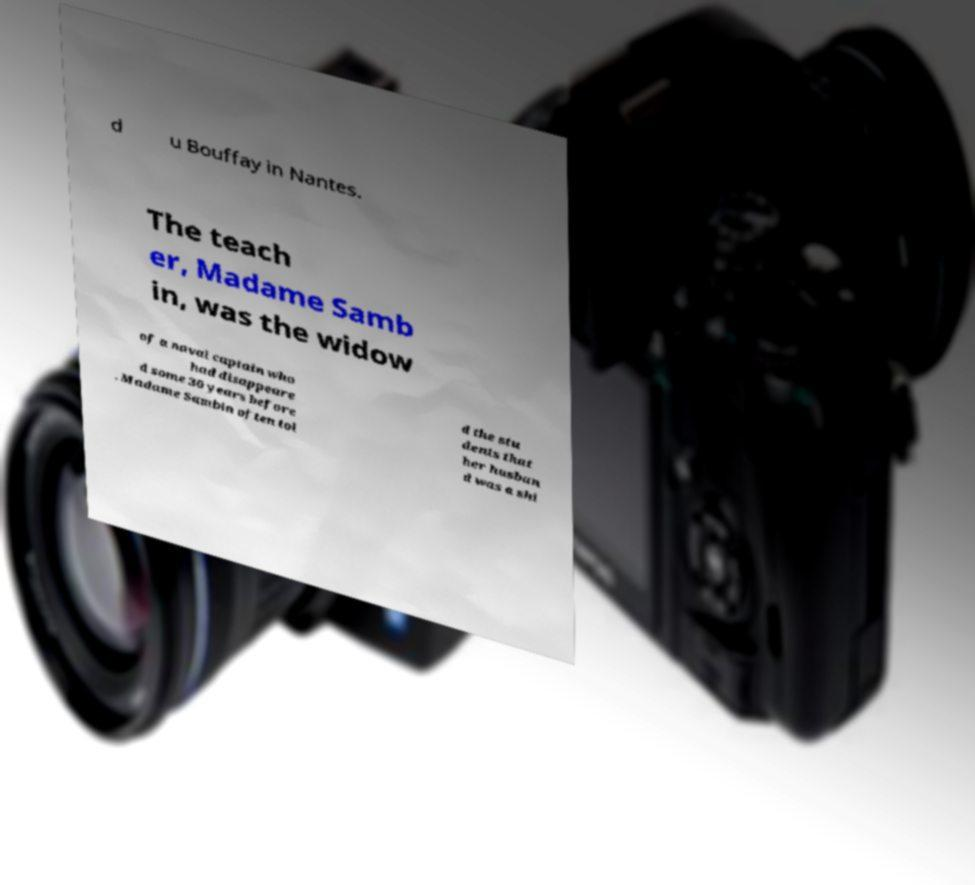Can you accurately transcribe the text from the provided image for me? d u Bouffay in Nantes. The teach er, Madame Samb in, was the widow of a naval captain who had disappeare d some 30 years before . Madame Sambin often tol d the stu dents that her husban d was a shi 